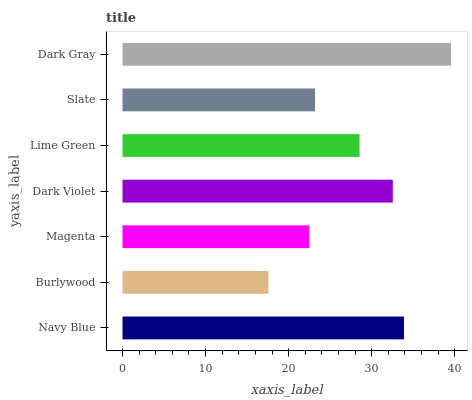Is Burlywood the minimum?
Answer yes or no. Yes. Is Dark Gray the maximum?
Answer yes or no. Yes. Is Magenta the minimum?
Answer yes or no. No. Is Magenta the maximum?
Answer yes or no. No. Is Magenta greater than Burlywood?
Answer yes or no. Yes. Is Burlywood less than Magenta?
Answer yes or no. Yes. Is Burlywood greater than Magenta?
Answer yes or no. No. Is Magenta less than Burlywood?
Answer yes or no. No. Is Lime Green the high median?
Answer yes or no. Yes. Is Lime Green the low median?
Answer yes or no. Yes. Is Magenta the high median?
Answer yes or no. No. Is Magenta the low median?
Answer yes or no. No. 